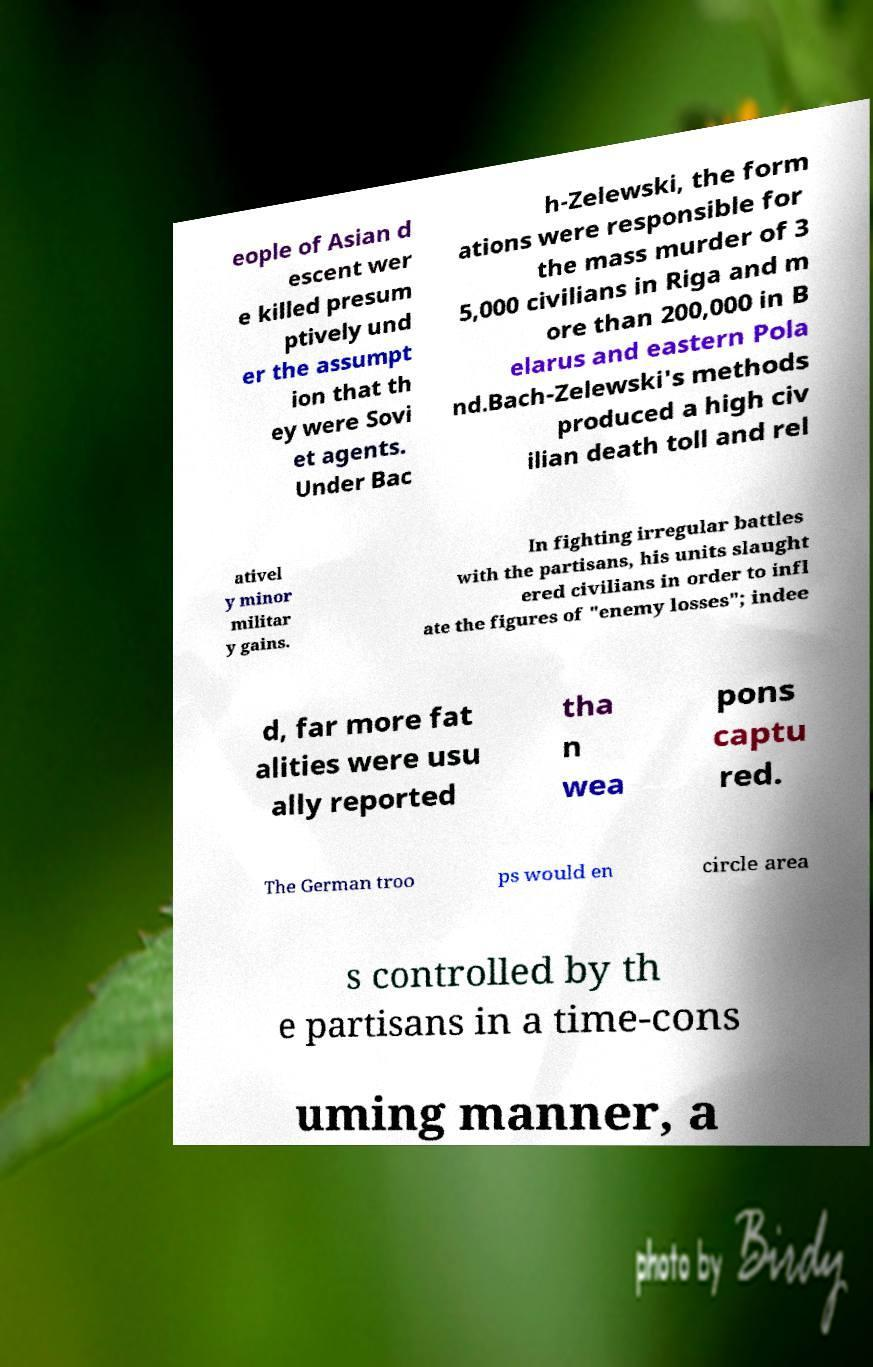Can you accurately transcribe the text from the provided image for me? eople of Asian d escent wer e killed presum ptively und er the assumpt ion that th ey were Sovi et agents. Under Bac h-Zelewski, the form ations were responsible for the mass murder of 3 5,000 civilians in Riga and m ore than 200,000 in B elarus and eastern Pola nd.Bach-Zelewski's methods produced a high civ ilian death toll and rel ativel y minor militar y gains. In fighting irregular battles with the partisans, his units slaught ered civilians in order to infl ate the figures of "enemy losses"; indee d, far more fat alities were usu ally reported tha n wea pons captu red. The German troo ps would en circle area s controlled by th e partisans in a time-cons uming manner, a 